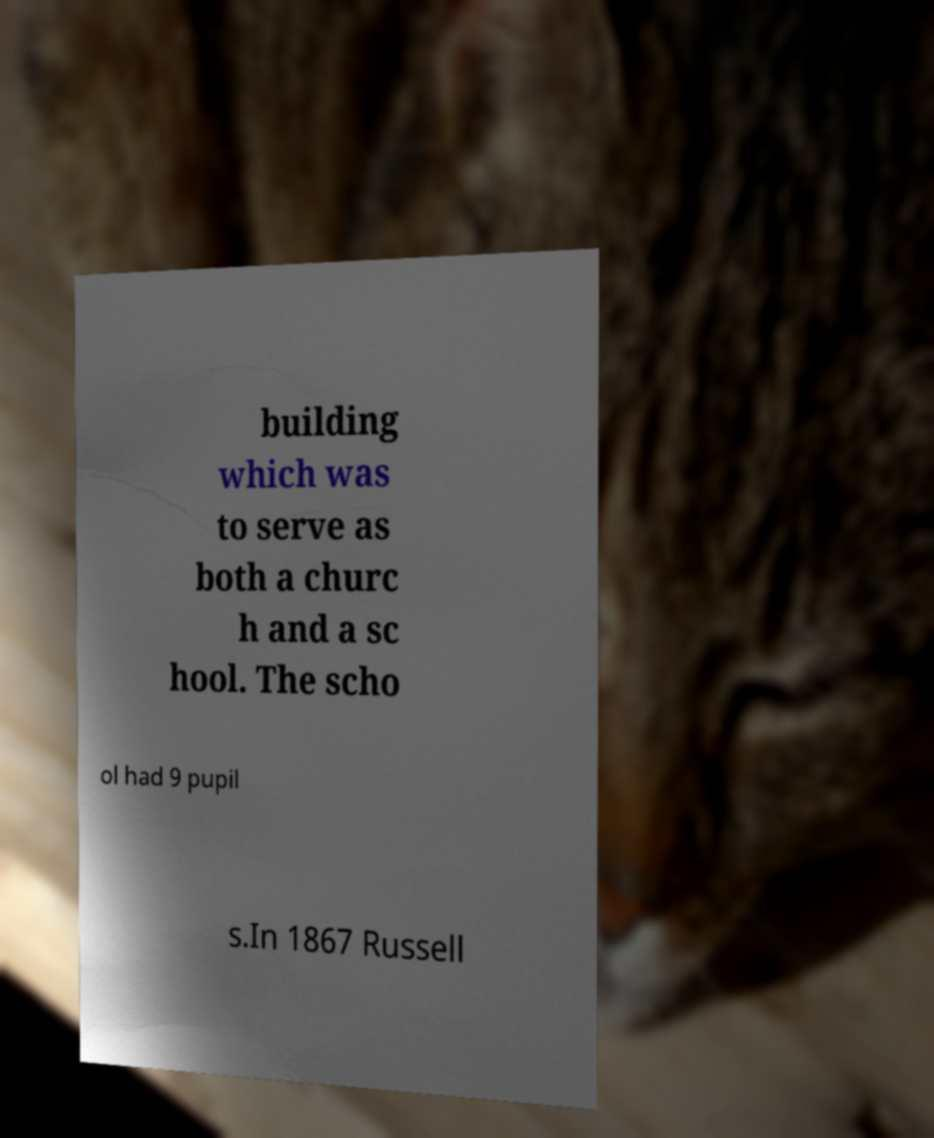Please read and relay the text visible in this image. What does it say? building which was to serve as both a churc h and a sc hool. The scho ol had 9 pupil s.In 1867 Russell 